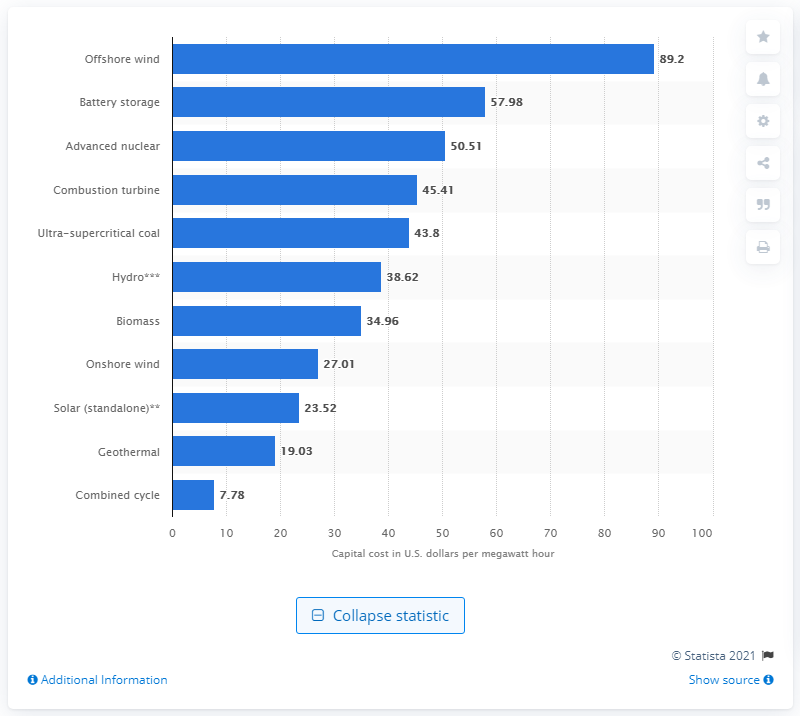Highlight a few significant elements in this photo. Offshore wind energy has one of the highest levelized capital costs of any energy source in the United States. According to estimates, the capital cost per megawatt hour for new offshore power generating sites entering the power grid in 2026 is expected to be approximately 89.2. 